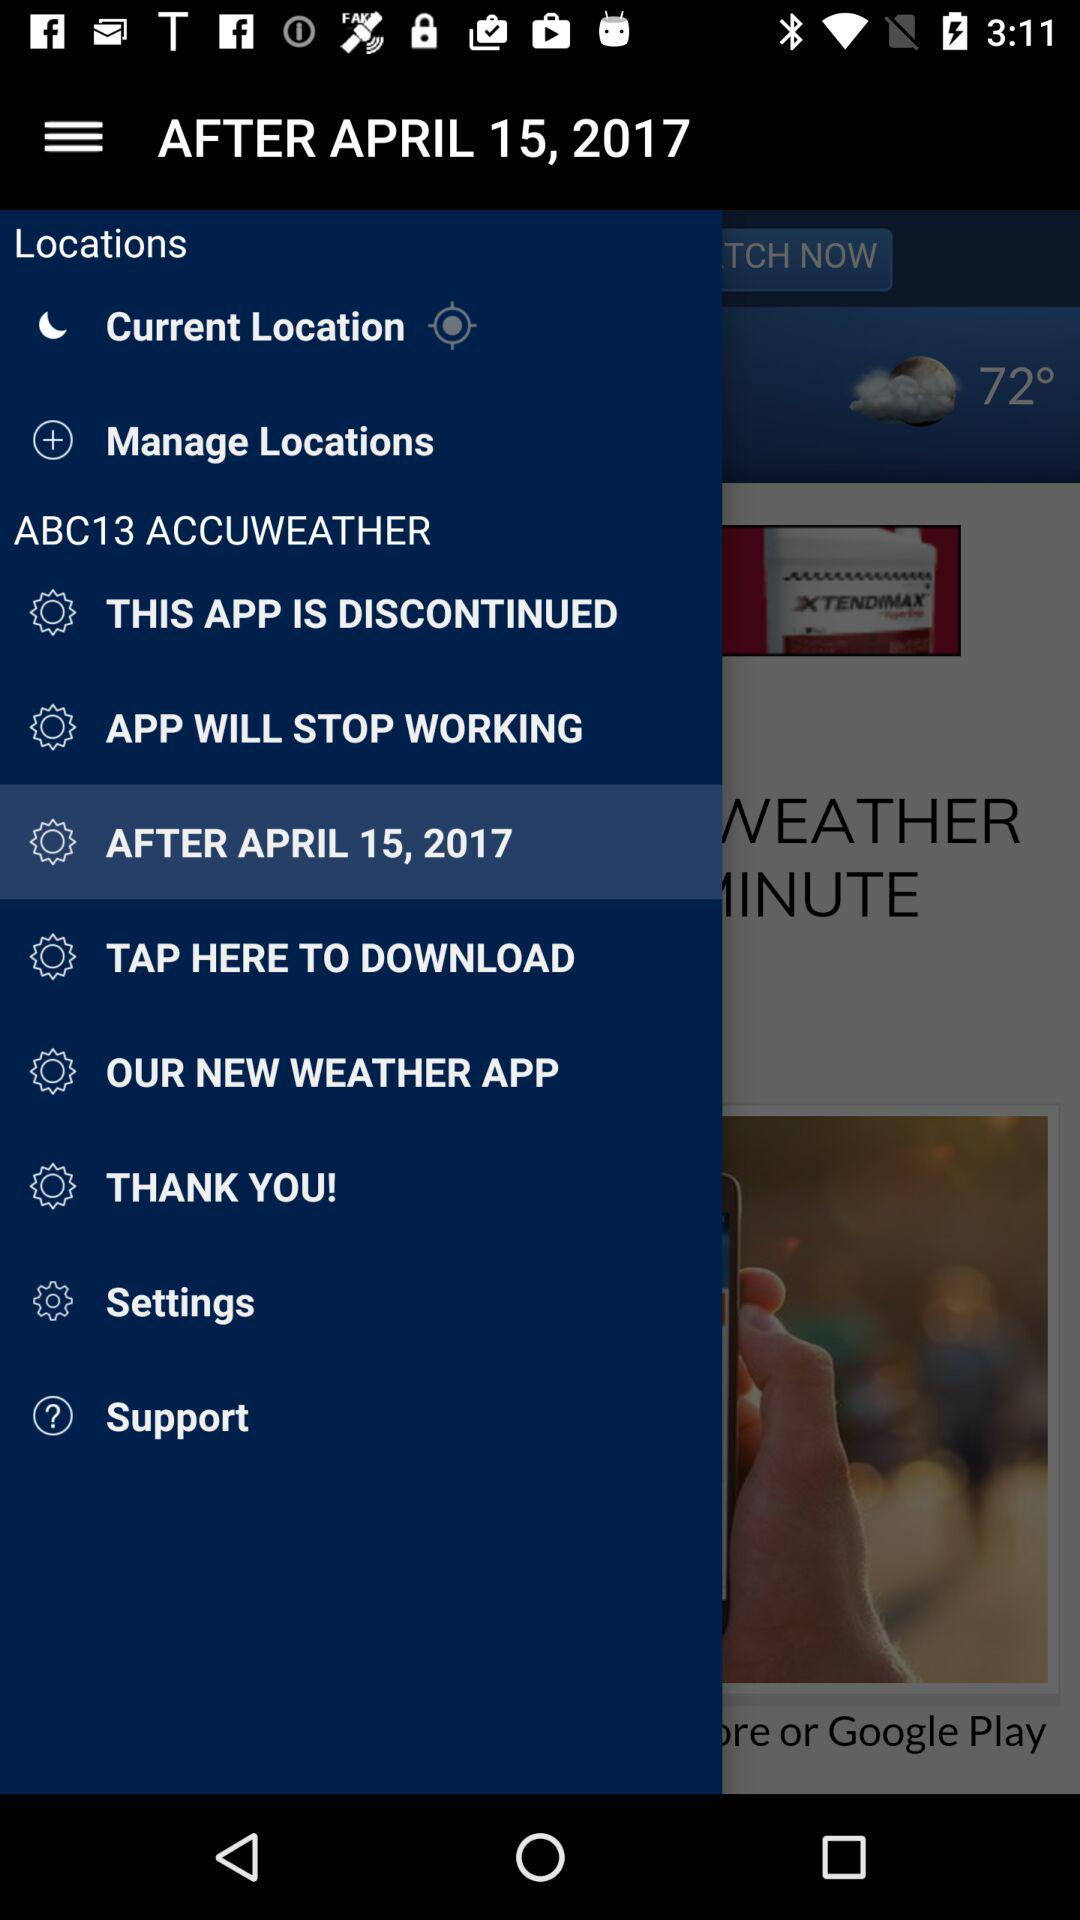What option is selected in "ABC13 ACCUWEATHER"? The selected option is "AFTER APRIL 15, 2017". 